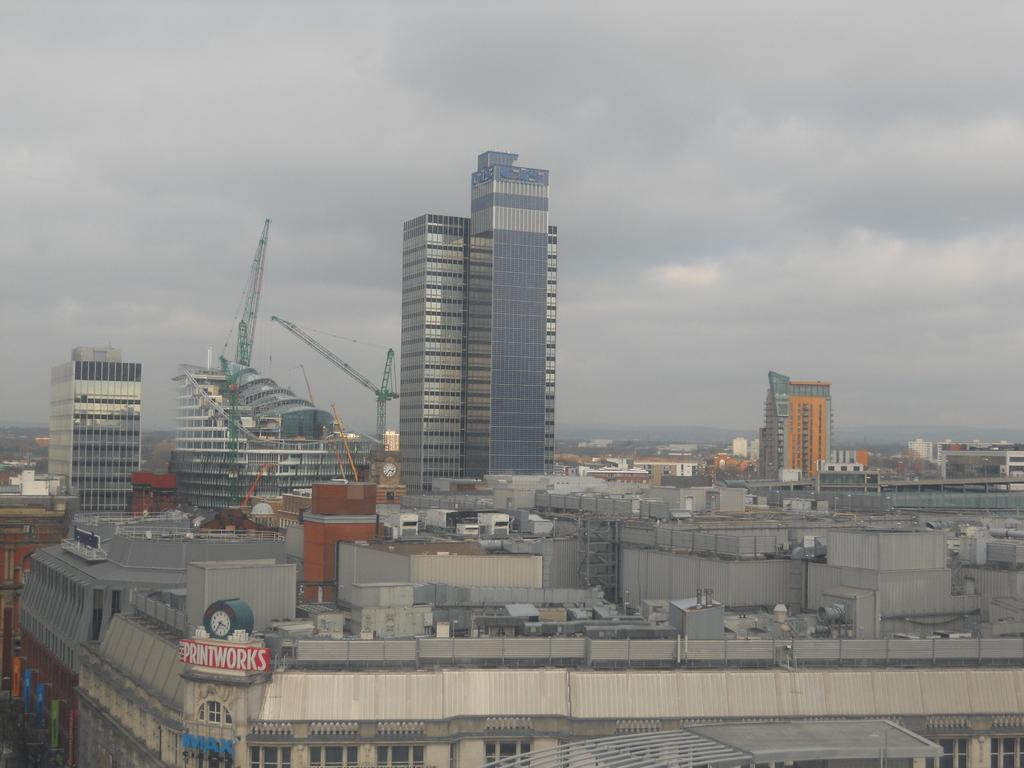What type of structures can be seen in the image? There are buildings and tower buildings in the image. Are there any specific features associated with the buildings? Yes, there are tower cranes visible in the image. What can be seen in the sky in the image? Clouds are visible in the sky. Can you see a record being played on the grass in the image? There is no record or grass present in the image; it features buildings and tower cranes with clouds in the sky. 